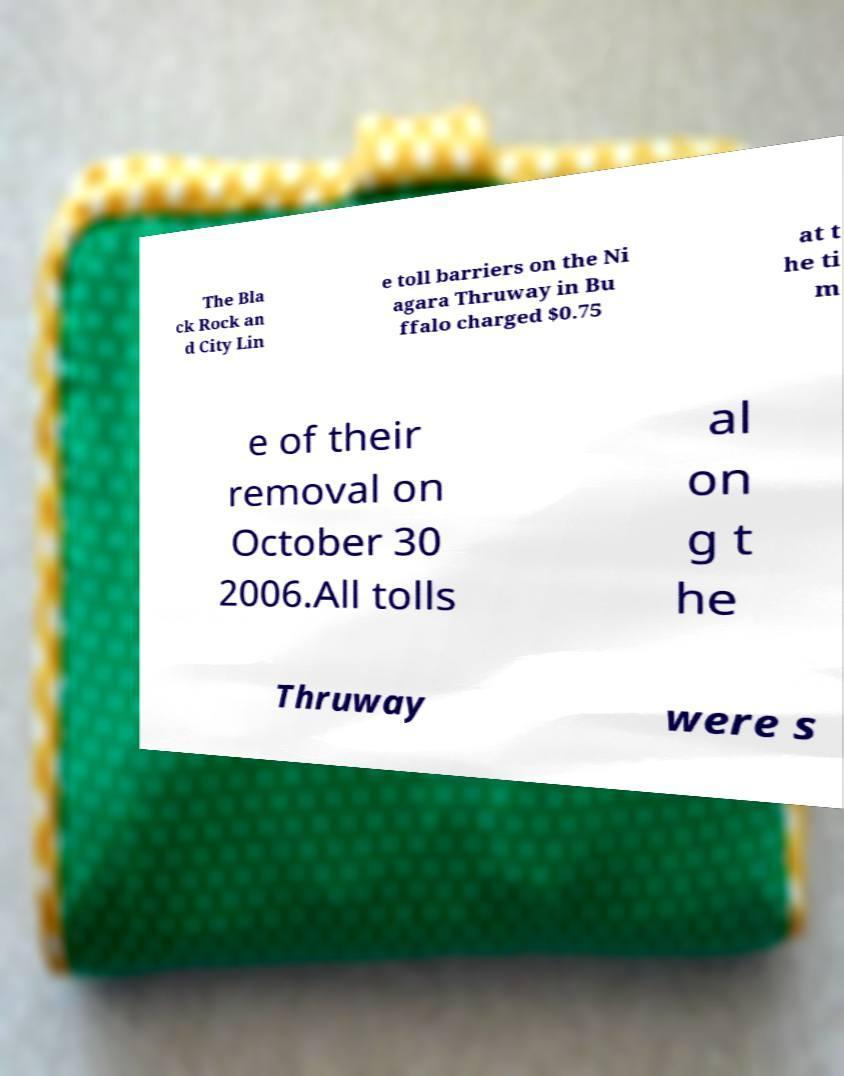There's text embedded in this image that I need extracted. Can you transcribe it verbatim? The Bla ck Rock an d City Lin e toll barriers on the Ni agara Thruway in Bu ffalo charged $0.75 at t he ti m e of their removal on October 30 2006.All tolls al on g t he Thruway were s 